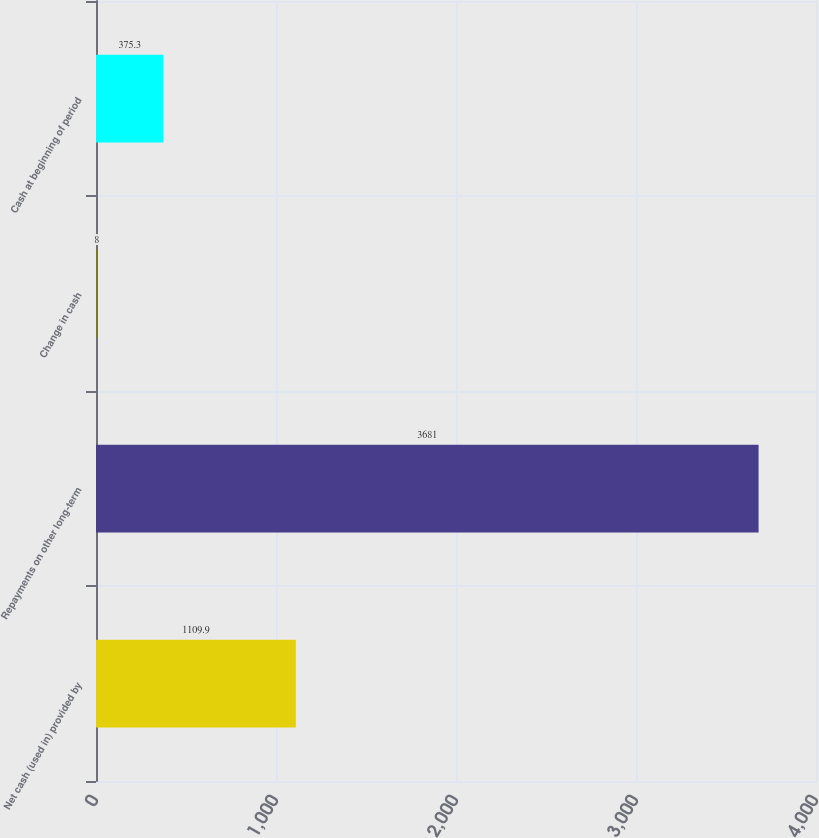<chart> <loc_0><loc_0><loc_500><loc_500><bar_chart><fcel>Net cash (used in) provided by<fcel>Repayments on other long-term<fcel>Change in cash<fcel>Cash at beginning of period<nl><fcel>1109.9<fcel>3681<fcel>8<fcel>375.3<nl></chart> 